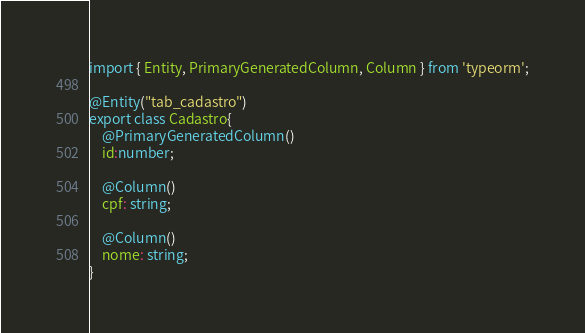<code> <loc_0><loc_0><loc_500><loc_500><_TypeScript_>import { Entity, PrimaryGeneratedColumn, Column } from 'typeorm';

@Entity("tab_cadastro")
export class Cadastro{
    @PrimaryGeneratedColumn()
    id:number;

    @Column()
    cpf: string;

    @Column()
    nome: string;
}</code> 